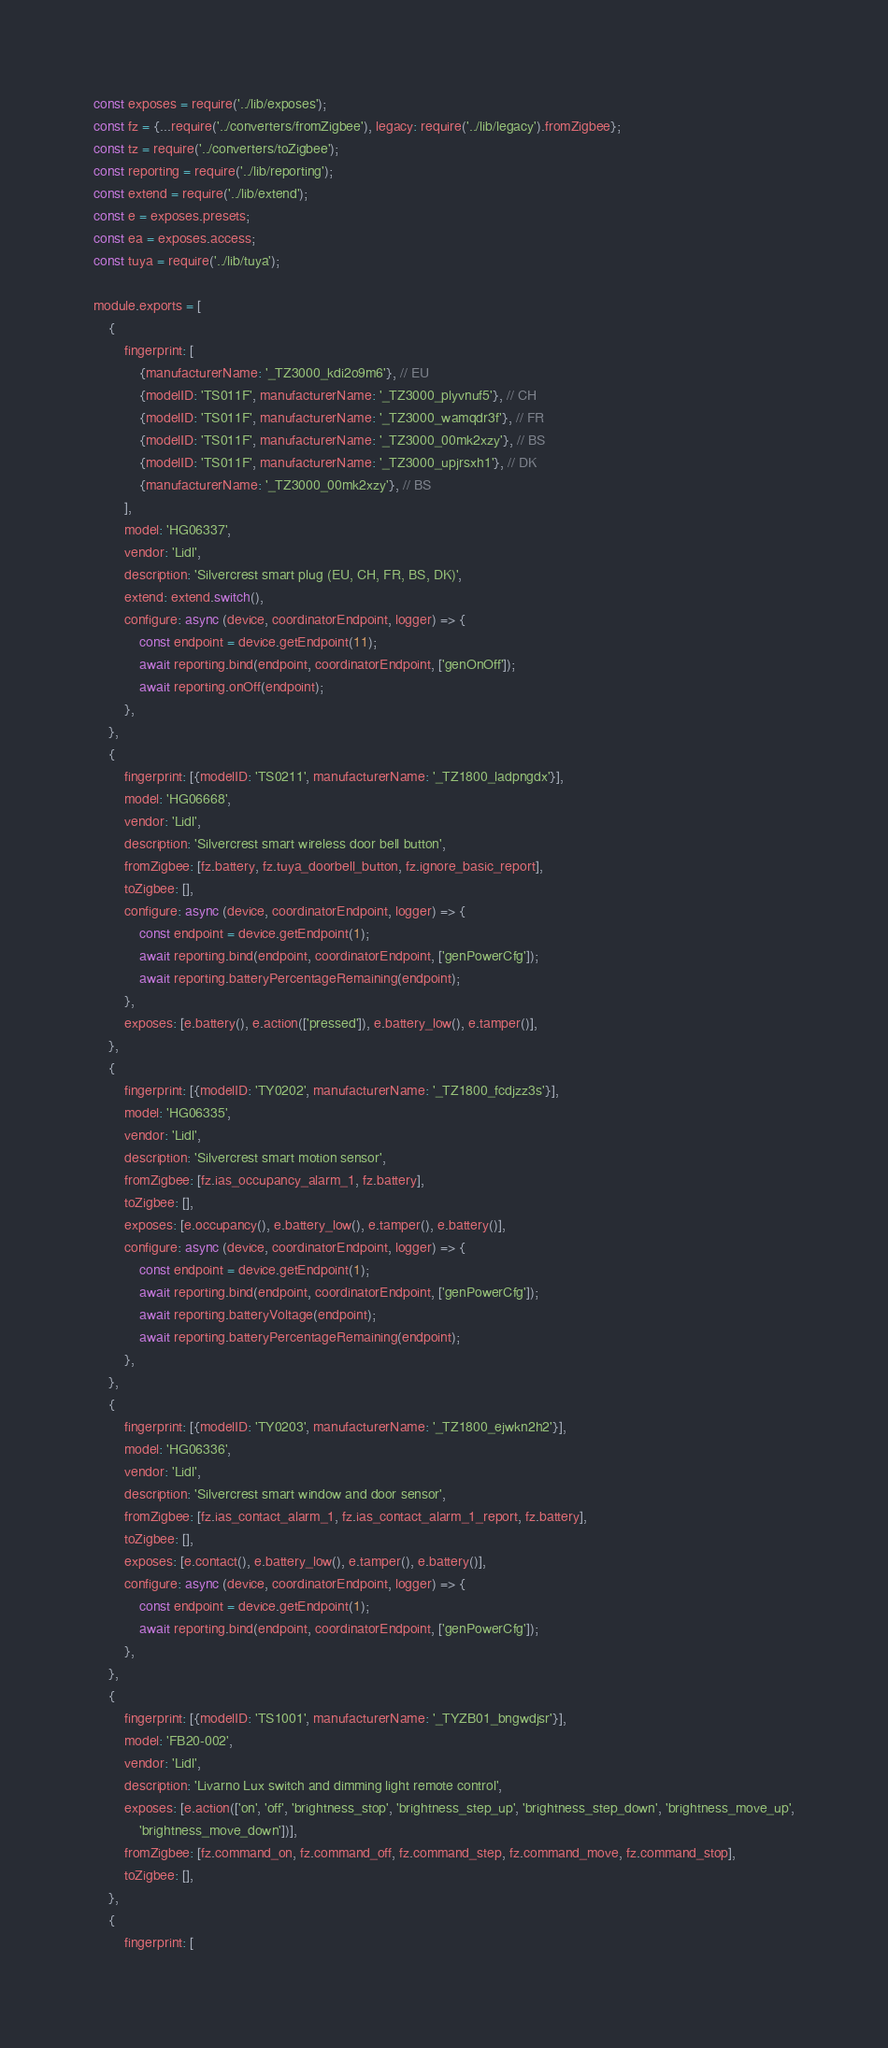Convert code to text. <code><loc_0><loc_0><loc_500><loc_500><_JavaScript_>const exposes = require('../lib/exposes');
const fz = {...require('../converters/fromZigbee'), legacy: require('../lib/legacy').fromZigbee};
const tz = require('../converters/toZigbee');
const reporting = require('../lib/reporting');
const extend = require('../lib/extend');
const e = exposes.presets;
const ea = exposes.access;
const tuya = require('../lib/tuya');

module.exports = [
    {
        fingerprint: [
            {manufacturerName: '_TZ3000_kdi2o9m6'}, // EU
            {modelID: 'TS011F', manufacturerName: '_TZ3000_plyvnuf5'}, // CH
            {modelID: 'TS011F', manufacturerName: '_TZ3000_wamqdr3f'}, // FR
            {modelID: 'TS011F', manufacturerName: '_TZ3000_00mk2xzy'}, // BS
            {modelID: 'TS011F', manufacturerName: '_TZ3000_upjrsxh1'}, // DK
            {manufacturerName: '_TZ3000_00mk2xzy'}, // BS
        ],
        model: 'HG06337',
        vendor: 'Lidl',
        description: 'Silvercrest smart plug (EU, CH, FR, BS, DK)',
        extend: extend.switch(),
        configure: async (device, coordinatorEndpoint, logger) => {
            const endpoint = device.getEndpoint(11);
            await reporting.bind(endpoint, coordinatorEndpoint, ['genOnOff']);
            await reporting.onOff(endpoint);
        },
    },
    {
        fingerprint: [{modelID: 'TS0211', manufacturerName: '_TZ1800_ladpngdx'}],
        model: 'HG06668',
        vendor: 'Lidl',
        description: 'Silvercrest smart wireless door bell button',
        fromZigbee: [fz.battery, fz.tuya_doorbell_button, fz.ignore_basic_report],
        toZigbee: [],
        configure: async (device, coordinatorEndpoint, logger) => {
            const endpoint = device.getEndpoint(1);
            await reporting.bind(endpoint, coordinatorEndpoint, ['genPowerCfg']);
            await reporting.batteryPercentageRemaining(endpoint);
        },
        exposes: [e.battery(), e.action(['pressed']), e.battery_low(), e.tamper()],
    },
    {
        fingerprint: [{modelID: 'TY0202', manufacturerName: '_TZ1800_fcdjzz3s'}],
        model: 'HG06335',
        vendor: 'Lidl',
        description: 'Silvercrest smart motion sensor',
        fromZigbee: [fz.ias_occupancy_alarm_1, fz.battery],
        toZigbee: [],
        exposes: [e.occupancy(), e.battery_low(), e.tamper(), e.battery()],
        configure: async (device, coordinatorEndpoint, logger) => {
            const endpoint = device.getEndpoint(1);
            await reporting.bind(endpoint, coordinatorEndpoint, ['genPowerCfg']);
            await reporting.batteryVoltage(endpoint);
            await reporting.batteryPercentageRemaining(endpoint);
        },
    },
    {
        fingerprint: [{modelID: 'TY0203', manufacturerName: '_TZ1800_ejwkn2h2'}],
        model: 'HG06336',
        vendor: 'Lidl',
        description: 'Silvercrest smart window and door sensor',
        fromZigbee: [fz.ias_contact_alarm_1, fz.ias_contact_alarm_1_report, fz.battery],
        toZigbee: [],
        exposes: [e.contact(), e.battery_low(), e.tamper(), e.battery()],
        configure: async (device, coordinatorEndpoint, logger) => {
            const endpoint = device.getEndpoint(1);
            await reporting.bind(endpoint, coordinatorEndpoint, ['genPowerCfg']);
        },
    },
    {
        fingerprint: [{modelID: 'TS1001', manufacturerName: '_TYZB01_bngwdjsr'}],
        model: 'FB20-002',
        vendor: 'Lidl',
        description: 'Livarno Lux switch and dimming light remote control',
        exposes: [e.action(['on', 'off', 'brightness_stop', 'brightness_step_up', 'brightness_step_down', 'brightness_move_up',
            'brightness_move_down'])],
        fromZigbee: [fz.command_on, fz.command_off, fz.command_step, fz.command_move, fz.command_stop],
        toZigbee: [],
    },
    {
        fingerprint: [</code> 